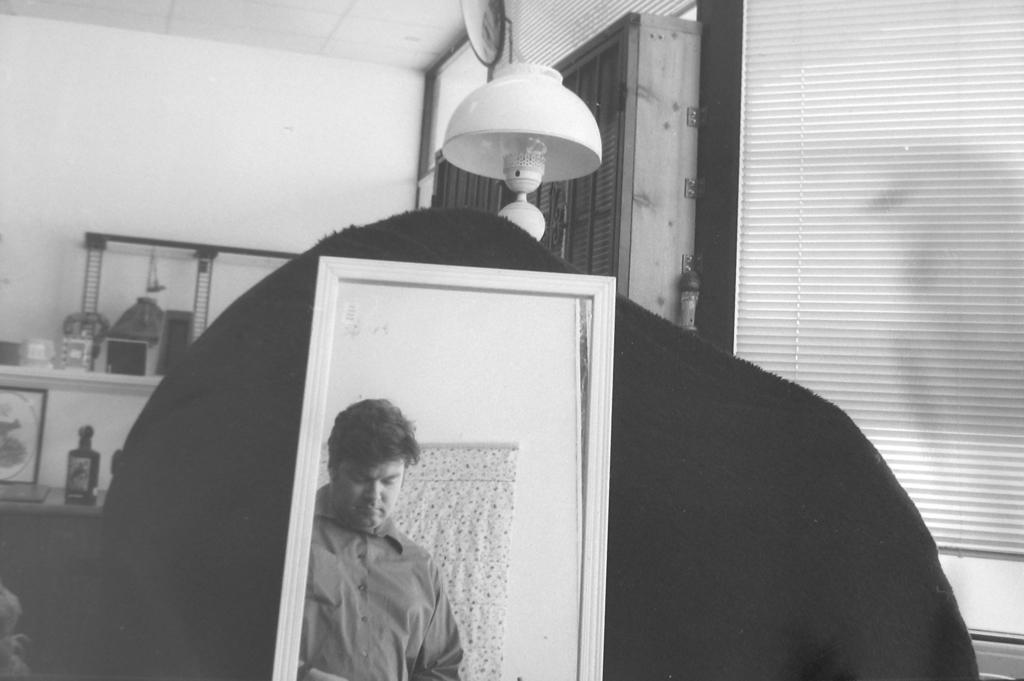What is one of the main objects in the image? There is a mirror in the image. What is happening in front of the mirror? A person is standing in front of the mirror. What can be seen behind the mirror? There is an object behind the mirror. What type of lighting is present in the image? There is a lamp in the background of the image. What else can be seen in the background of the image? There are other objects present in the background of the image. What type of rose is being held by the person in the image? There is no rose present in the image; the person is standing in front of a mirror. How many pears are visible on the table in the image? There are no pears visible in the image; the focus is on the mirror, person, and objects in the background. 